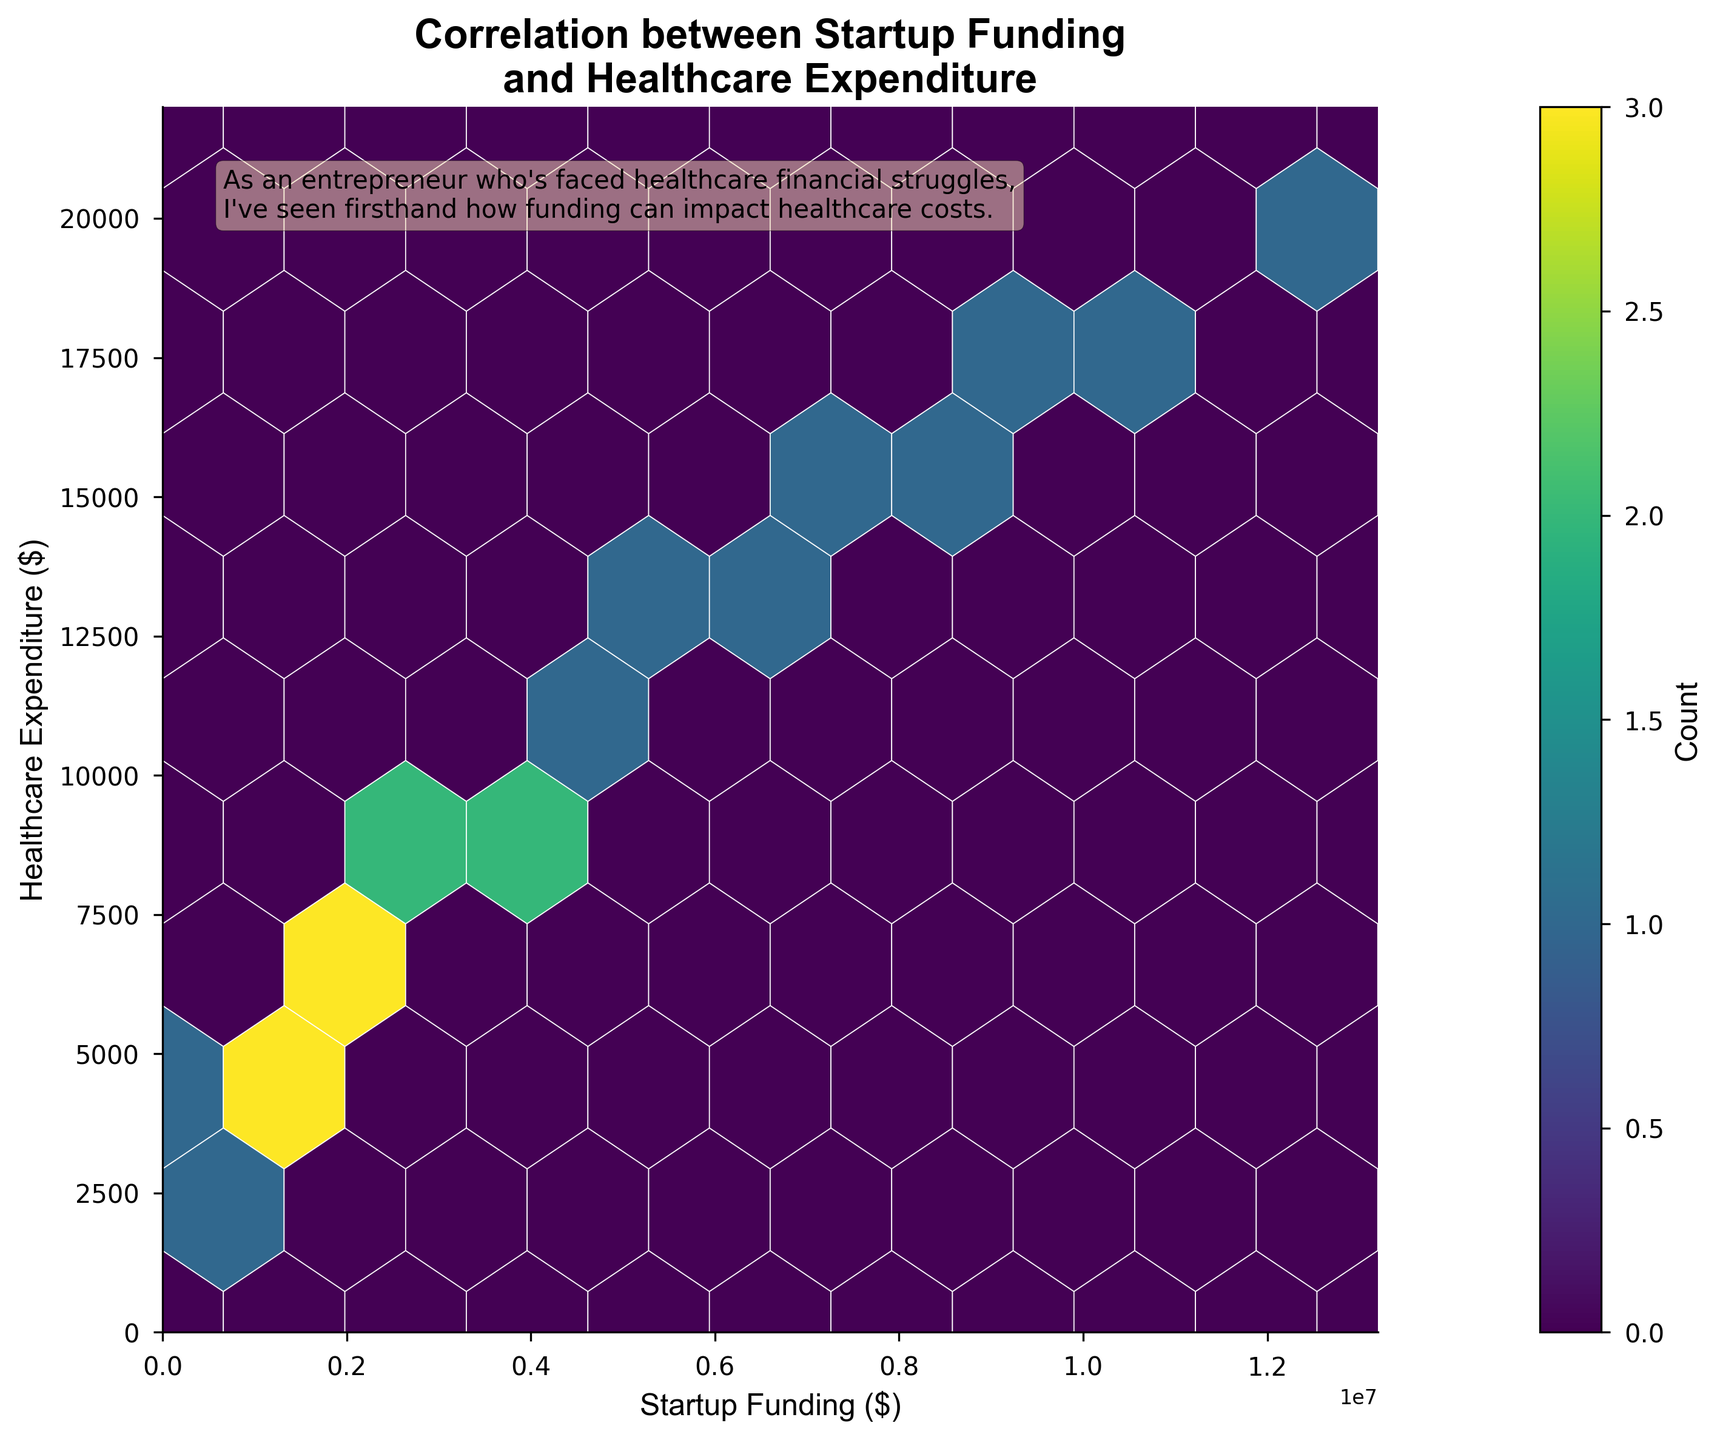What's the title of the plot? The title is written in bold at the top of the plot, reading 'Correlation between Startup Funding and Healthcare Expenditure'.
Answer: Correlation between Startup Funding and Healthcare Expenditure What are the units on the x-axis and y-axis? The labels on the axes indicate the units with '$', meaning both x-axis and y-axis are measured in dollars.
Answer: Dollars What's the range of the x-axis? The x-axis starts at 0 and ends approximately a bit above 13 million, as it has a maximum funding value plus an additional 10%.
Answer: 0 to around 13 million What's the range of the y-axis? The y-axis starts at 0 and ends approximately a bit above 22 thousand, as it has a maximum expense value plus an additional 10%.
Answer: 0 to around 22 thousand How many bins are used in this plot? The gridsize is set to 10, meaning the x and y axes are each split into 10 segments, creating a 10x10 grid of bins.
Answer: 10 What is the color indicating in the plot? The color in the hexbin plot represents the count of data points within each hexagonal bin, with darker colors indicating higher counts, as shown by the color gradient and the colorbar labeled 'Count'.
Answer: Count of data points Where is the highest concentration of data points found? The highest concentration is indicated by the darkest color and is found in the region where startup funding is roughly between 1 and 3 million dollars and healthcare expenditure is roughly between 5 to 10 thousand dollars.
Answer: Around 1-3 million dollars funding and 5-10 thousand dollars expenditure Which has higher funding, a startup with 15,000 dollars healthcare expenditure or one with 5,000 dollars healthcare expenditure? In general, the higher funding is associated with the higher expenditure. The 15,000 dollars healthcare expenditure aligns with higher funding values compared to the 5,000 dollars healthcare expenditure.
Answer: 15,000 dollars healthcare expenditure If a startup spends 7,500 dollars on healthcare, estimate its funding from the plot. From the plot, startups with around 7,500 dollars healthcare expenditure are typically associated with funding around 2-3 million dollars.
Answer: 2-3 million dollars What does the text box in the top left corner say about the entrepreneurial experience? The text box mentions how the author, as an entrepreneur who's faced healthcare financial struggles, has seen firsthand how funding can impact healthcare costs.
Answer: Impact of funding on healthcare costs 